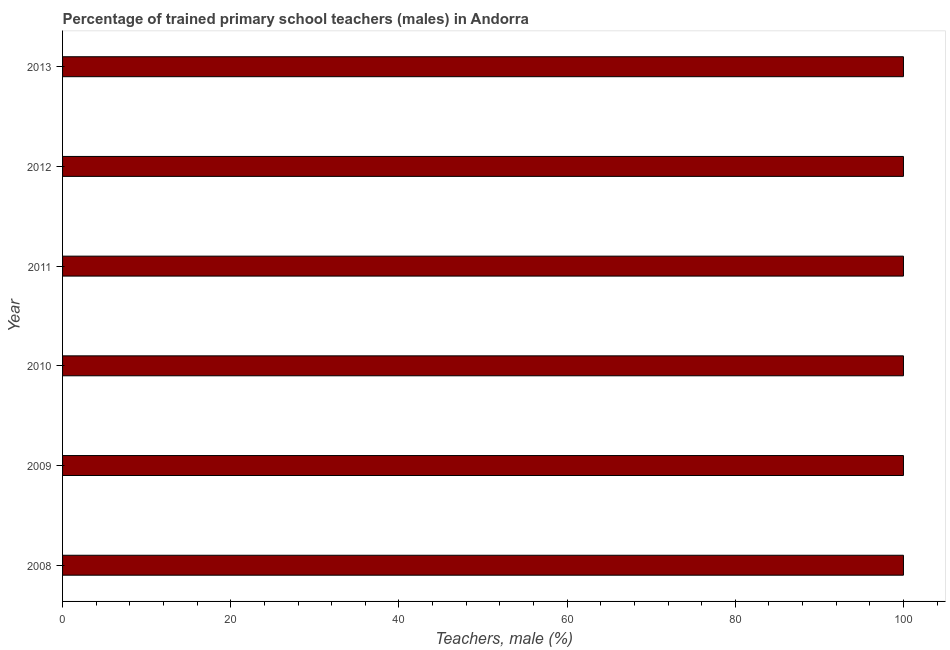Does the graph contain grids?
Make the answer very short. No. What is the title of the graph?
Offer a terse response. Percentage of trained primary school teachers (males) in Andorra. What is the label or title of the X-axis?
Ensure brevity in your answer.  Teachers, male (%). What is the label or title of the Y-axis?
Give a very brief answer. Year. What is the percentage of trained male teachers in 2008?
Keep it short and to the point. 100. In which year was the percentage of trained male teachers minimum?
Your response must be concise. 2008. What is the sum of the percentage of trained male teachers?
Offer a terse response. 600. In how many years, is the percentage of trained male teachers greater than 52 %?
Your answer should be compact. 6. What is the ratio of the percentage of trained male teachers in 2011 to that in 2012?
Provide a succinct answer. 1. Is the percentage of trained male teachers in 2012 less than that in 2013?
Your answer should be compact. No. Is the sum of the percentage of trained male teachers in 2011 and 2013 greater than the maximum percentage of trained male teachers across all years?
Offer a terse response. Yes. What is the difference between the highest and the lowest percentage of trained male teachers?
Offer a very short reply. 0. In how many years, is the percentage of trained male teachers greater than the average percentage of trained male teachers taken over all years?
Your response must be concise. 0. How many years are there in the graph?
Your response must be concise. 6. Are the values on the major ticks of X-axis written in scientific E-notation?
Offer a very short reply. No. What is the Teachers, male (%) in 2012?
Ensure brevity in your answer.  100. What is the Teachers, male (%) of 2013?
Your answer should be very brief. 100. What is the difference between the Teachers, male (%) in 2008 and 2010?
Make the answer very short. 0. What is the difference between the Teachers, male (%) in 2008 and 2011?
Offer a very short reply. 0. What is the difference between the Teachers, male (%) in 2008 and 2012?
Provide a short and direct response. 0. What is the difference between the Teachers, male (%) in 2008 and 2013?
Ensure brevity in your answer.  0. What is the difference between the Teachers, male (%) in 2009 and 2010?
Keep it short and to the point. 0. What is the difference between the Teachers, male (%) in 2009 and 2012?
Offer a very short reply. 0. What is the difference between the Teachers, male (%) in 2010 and 2011?
Your response must be concise. 0. What is the difference between the Teachers, male (%) in 2010 and 2012?
Give a very brief answer. 0. What is the difference between the Teachers, male (%) in 2011 and 2012?
Make the answer very short. 0. What is the difference between the Teachers, male (%) in 2012 and 2013?
Make the answer very short. 0. What is the ratio of the Teachers, male (%) in 2008 to that in 2010?
Give a very brief answer. 1. What is the ratio of the Teachers, male (%) in 2008 to that in 2011?
Offer a terse response. 1. What is the ratio of the Teachers, male (%) in 2008 to that in 2012?
Your response must be concise. 1. What is the ratio of the Teachers, male (%) in 2009 to that in 2010?
Give a very brief answer. 1. What is the ratio of the Teachers, male (%) in 2009 to that in 2011?
Your response must be concise. 1. What is the ratio of the Teachers, male (%) in 2009 to that in 2012?
Provide a short and direct response. 1. What is the ratio of the Teachers, male (%) in 2009 to that in 2013?
Provide a short and direct response. 1. 